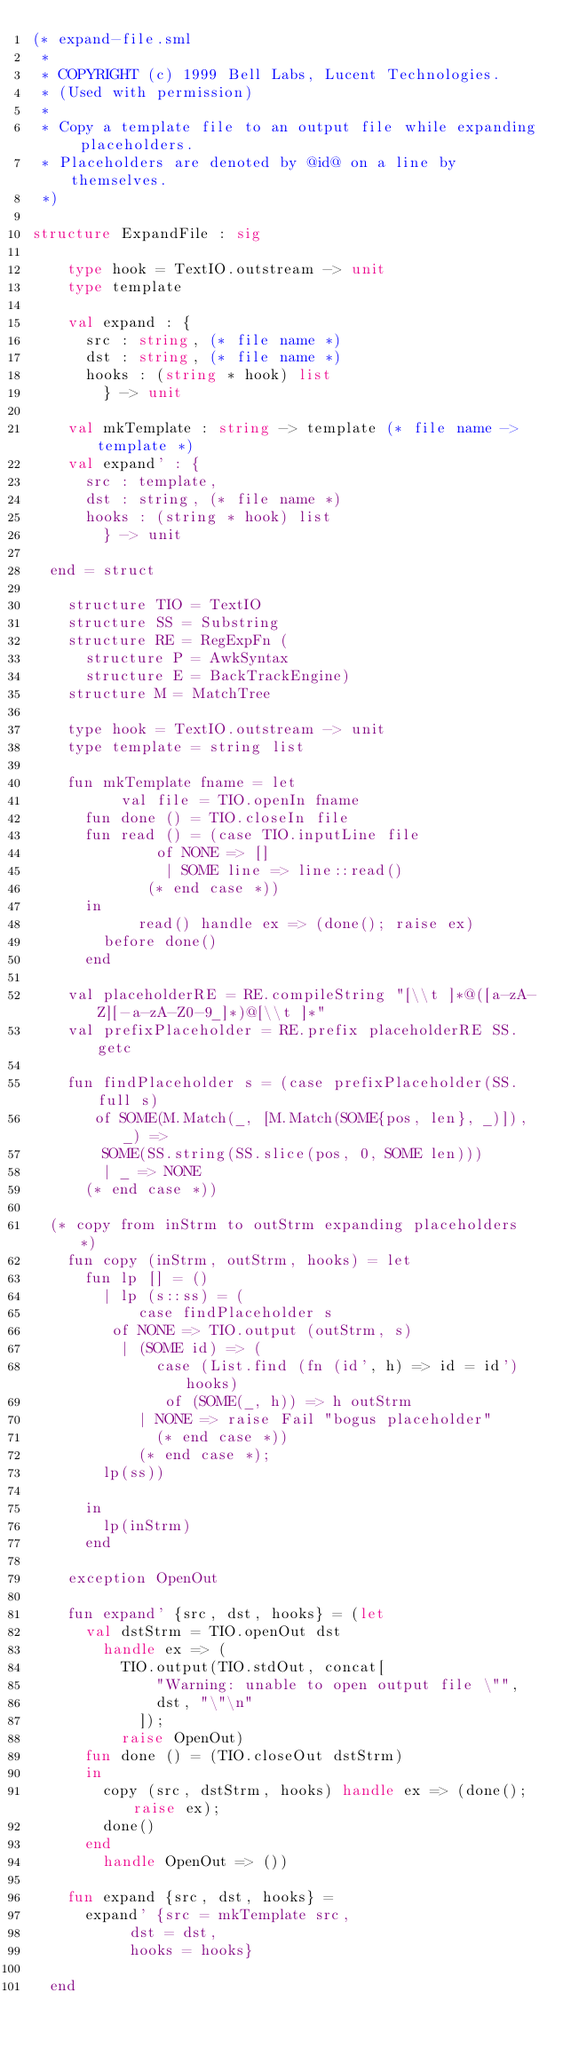Convert code to text. <code><loc_0><loc_0><loc_500><loc_500><_SML_>(* expand-file.sml
 *
 * COPYRIGHT (c) 1999 Bell Labs, Lucent Technologies.
 * (Used with permission)
 *
 * Copy a template file to an output file while expanding placeholders.
 * Placeholders are denoted by @id@ on a line by themselves.
 *)

structure ExpandFile : sig

    type hook = TextIO.outstream -> unit
    type template

    val expand : {
	  src : string, (* file name *)
	  dst : string, (* file name *)
	  hooks : (string * hook) list
        } -> unit

    val mkTemplate : string -> template (* file name -> template *)
    val expand' : {
	  src : template, 
	  dst : string, (* file name *)
	  hooks : (string * hook) list
        } -> unit

  end = struct

    structure TIO = TextIO
    structure SS = Substring
    structure RE = RegExpFn (
      structure P = AwkSyntax
      structure E = BackTrackEngine)
    structure M = MatchTree

    type hook = TextIO.outstream -> unit
    type template = string list

    fun mkTemplate fname = let
          val file = TIO.openIn fname
	  fun done () = TIO.closeIn file
	  fun read () = (case TIO.inputLine file
			  of NONE => []
			   | SOME line => line::read()
			 (* end case *))
	  in 
            read() handle ex => (done(); raise ex)
	    before done()
	  end

    val placeholderRE = RE.compileString "[\\t ]*@([a-zA-Z][-a-zA-Z0-9_]*)@[\\t ]*"
    val prefixPlaceholder = RE.prefix placeholderRE SS.getc

    fun findPlaceholder s = (case prefixPlaceholder(SS.full s)
	   of SOME(M.Match(_, [M.Match(SOME{pos, len}, _)]), _) =>
		SOME(SS.string(SS.slice(pos, 0, SOME len)))
	    | _ => NONE
	  (* end case *))

  (* copy from inStrm to outStrm expanding placeholders *)
    fun copy (inStrm, outStrm, hooks) = let
	  fun lp [] = ()
	    | lp (s::ss) = (
	        case findPlaceholder s
		 of NONE => TIO.output (outStrm, s)
		  | (SOME id) => (
		      case (List.find (fn (id', h) => id = id') hooks)
		       of (SOME(_, h)) => h outStrm
			| NONE => raise Fail "bogus placeholder"
		      (* end case *))
	        (* end case *);
		lp(ss))
		
	  in
	    lp(inStrm)
	  end

    exception OpenOut

    fun expand' {src, dst, hooks} = (let
	  val dstStrm = TIO.openOut dst
		handle ex => (
		  TIO.output(TIO.stdOut, concat[
		      "Warning: unable to open output file \"",
		      dst, "\"\n"
		    ]);
		  raise OpenOut)
	  fun done () = (TIO.closeOut dstStrm)
	  in
	    copy (src, dstStrm, hooks) handle ex => (done(); raise ex);
	    done()
	  end
	    handle OpenOut => ())

    fun expand {src, dst, hooks} = 
	  expand' {src = mkTemplate src, 
		   dst = dst, 
		   hooks = hooks}

  end
</code> 